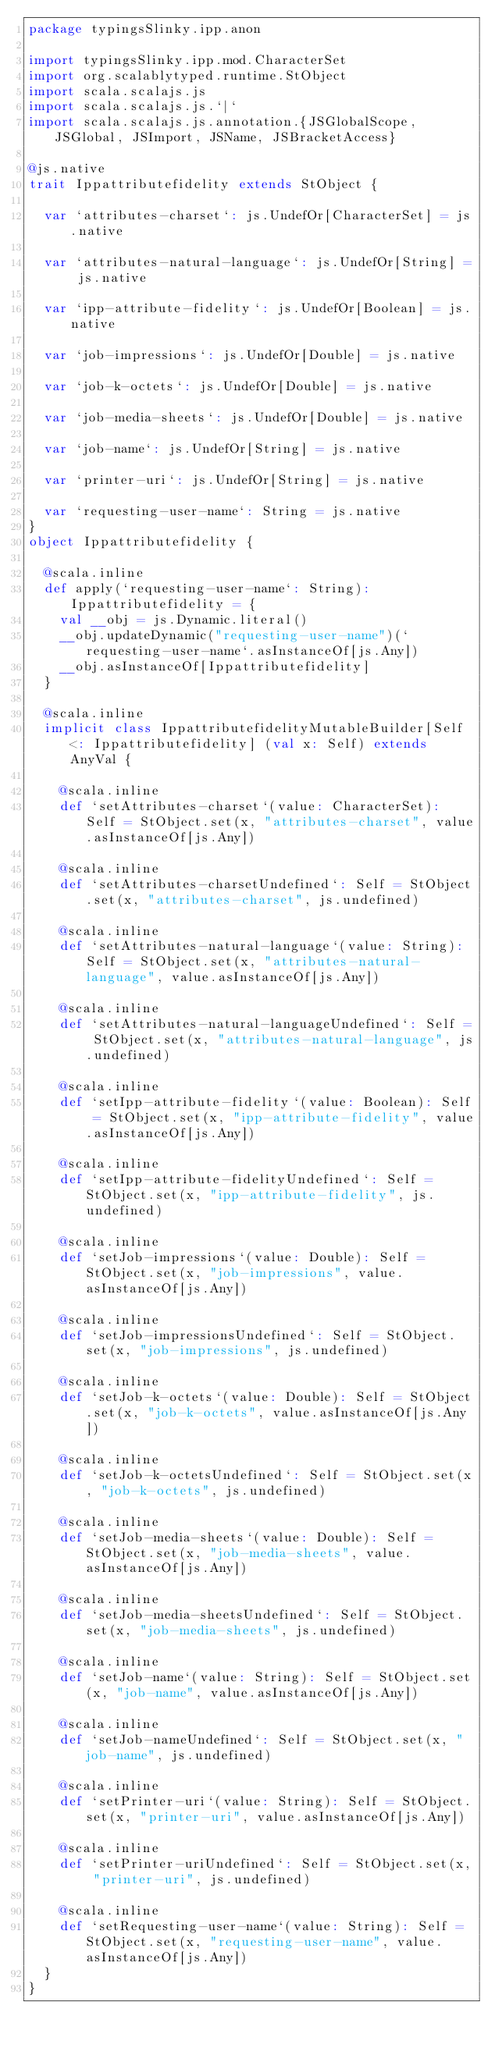<code> <loc_0><loc_0><loc_500><loc_500><_Scala_>package typingsSlinky.ipp.anon

import typingsSlinky.ipp.mod.CharacterSet
import org.scalablytyped.runtime.StObject
import scala.scalajs.js
import scala.scalajs.js.`|`
import scala.scalajs.js.annotation.{JSGlobalScope, JSGlobal, JSImport, JSName, JSBracketAccess}

@js.native
trait Ippattributefidelity extends StObject {
  
  var `attributes-charset`: js.UndefOr[CharacterSet] = js.native
  
  var `attributes-natural-language`: js.UndefOr[String] = js.native
  
  var `ipp-attribute-fidelity`: js.UndefOr[Boolean] = js.native
  
  var `job-impressions`: js.UndefOr[Double] = js.native
  
  var `job-k-octets`: js.UndefOr[Double] = js.native
  
  var `job-media-sheets`: js.UndefOr[Double] = js.native
  
  var `job-name`: js.UndefOr[String] = js.native
  
  var `printer-uri`: js.UndefOr[String] = js.native
  
  var `requesting-user-name`: String = js.native
}
object Ippattributefidelity {
  
  @scala.inline
  def apply(`requesting-user-name`: String): Ippattributefidelity = {
    val __obj = js.Dynamic.literal()
    __obj.updateDynamic("requesting-user-name")(`requesting-user-name`.asInstanceOf[js.Any])
    __obj.asInstanceOf[Ippattributefidelity]
  }
  
  @scala.inline
  implicit class IppattributefidelityMutableBuilder[Self <: Ippattributefidelity] (val x: Self) extends AnyVal {
    
    @scala.inline
    def `setAttributes-charset`(value: CharacterSet): Self = StObject.set(x, "attributes-charset", value.asInstanceOf[js.Any])
    
    @scala.inline
    def `setAttributes-charsetUndefined`: Self = StObject.set(x, "attributes-charset", js.undefined)
    
    @scala.inline
    def `setAttributes-natural-language`(value: String): Self = StObject.set(x, "attributes-natural-language", value.asInstanceOf[js.Any])
    
    @scala.inline
    def `setAttributes-natural-languageUndefined`: Self = StObject.set(x, "attributes-natural-language", js.undefined)
    
    @scala.inline
    def `setIpp-attribute-fidelity`(value: Boolean): Self = StObject.set(x, "ipp-attribute-fidelity", value.asInstanceOf[js.Any])
    
    @scala.inline
    def `setIpp-attribute-fidelityUndefined`: Self = StObject.set(x, "ipp-attribute-fidelity", js.undefined)
    
    @scala.inline
    def `setJob-impressions`(value: Double): Self = StObject.set(x, "job-impressions", value.asInstanceOf[js.Any])
    
    @scala.inline
    def `setJob-impressionsUndefined`: Self = StObject.set(x, "job-impressions", js.undefined)
    
    @scala.inline
    def `setJob-k-octets`(value: Double): Self = StObject.set(x, "job-k-octets", value.asInstanceOf[js.Any])
    
    @scala.inline
    def `setJob-k-octetsUndefined`: Self = StObject.set(x, "job-k-octets", js.undefined)
    
    @scala.inline
    def `setJob-media-sheets`(value: Double): Self = StObject.set(x, "job-media-sheets", value.asInstanceOf[js.Any])
    
    @scala.inline
    def `setJob-media-sheetsUndefined`: Self = StObject.set(x, "job-media-sheets", js.undefined)
    
    @scala.inline
    def `setJob-name`(value: String): Self = StObject.set(x, "job-name", value.asInstanceOf[js.Any])
    
    @scala.inline
    def `setJob-nameUndefined`: Self = StObject.set(x, "job-name", js.undefined)
    
    @scala.inline
    def `setPrinter-uri`(value: String): Self = StObject.set(x, "printer-uri", value.asInstanceOf[js.Any])
    
    @scala.inline
    def `setPrinter-uriUndefined`: Self = StObject.set(x, "printer-uri", js.undefined)
    
    @scala.inline
    def `setRequesting-user-name`(value: String): Self = StObject.set(x, "requesting-user-name", value.asInstanceOf[js.Any])
  }
}
</code> 